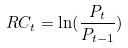Convert formula to latex. <formula><loc_0><loc_0><loc_500><loc_500>R C _ { t } = \ln ( \frac { P _ { t } } { P _ { t - 1 } } )</formula> 